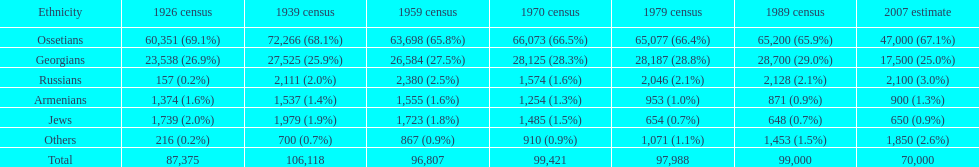Who is previous of the russians based on the list? Georgians. 